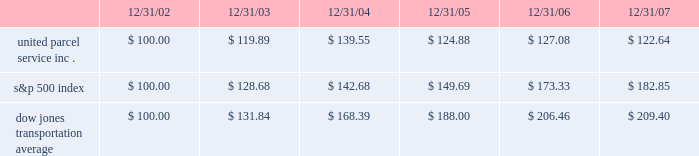Shareowner return performance graph the following performance graph and related information shall not be deemed 201csoliciting material 201d or to be 201cfiled 201d with the securities and exchange commission , nor shall such information be incorporated by reference into any future filing under the securities act of 1933 or securities exchange act of 1934 , each as amended , except to the extent that the company specifically incorporates such information by reference into such filing .
The following graph shows a five-year comparison of cumulative total shareowners 2019 returns for our class b common stock , the s&p 500 index , and the dow jones transportation average .
The comparison of the total cumulative return on investment , which is the change in the quarterly stock price plus reinvested dividends for each of the quarterly periods , assumes that $ 100 was invested on december 31 , 2002 in the s&p 500 index , the dow jones transportation average , and the class b common stock of united parcel service , inc .
Comparison of five year cumulative total return $ 40.00 $ 60.00 $ 80.00 $ 100.00 $ 120.00 $ 140.00 $ 160.00 $ 180.00 $ 200.00 $ 220.00 2002 20072006200520042003 s&p 500 ups dj transport .
Securities authorized for issuance under equity compensation plans the following table provides information as of december 31 , 2007 regarding compensation plans under which our class a common stock is authorized for issuance .
These plans do not authorize the issuance of our class b common stock. .
What was the difference in percentage five year cumulative total return for united parcel service inc . versus the s&p 500 index for the period ended 12/31/07? 
Computations: (((122.64 - 100) / 100) - ((182.85 - 100) / 100))
Answer: -0.6021. 